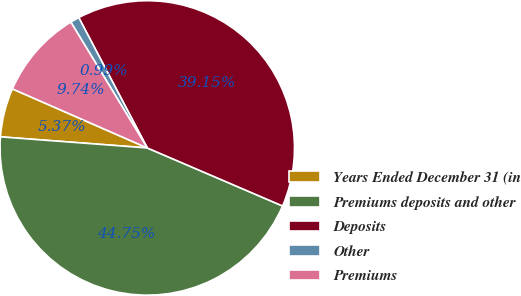Convert chart. <chart><loc_0><loc_0><loc_500><loc_500><pie_chart><fcel>Years Ended December 31 (in<fcel>Premiums deposits and other<fcel>Deposits<fcel>Other<fcel>Premiums<nl><fcel>5.37%<fcel>44.75%<fcel>39.15%<fcel>0.99%<fcel>9.74%<nl></chart> 